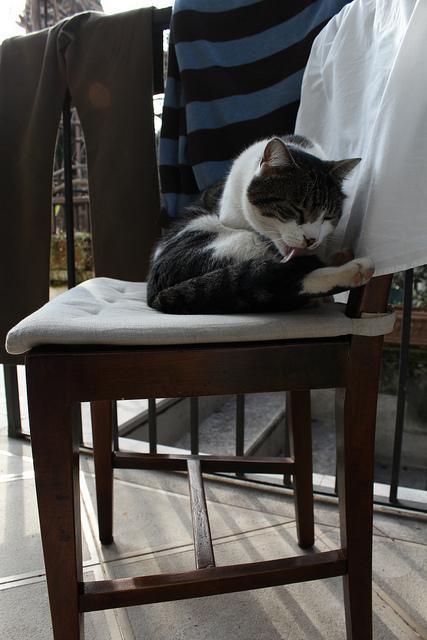How many chairs can you see?
Give a very brief answer. 1. How many white surfboards are there?
Give a very brief answer. 0. 